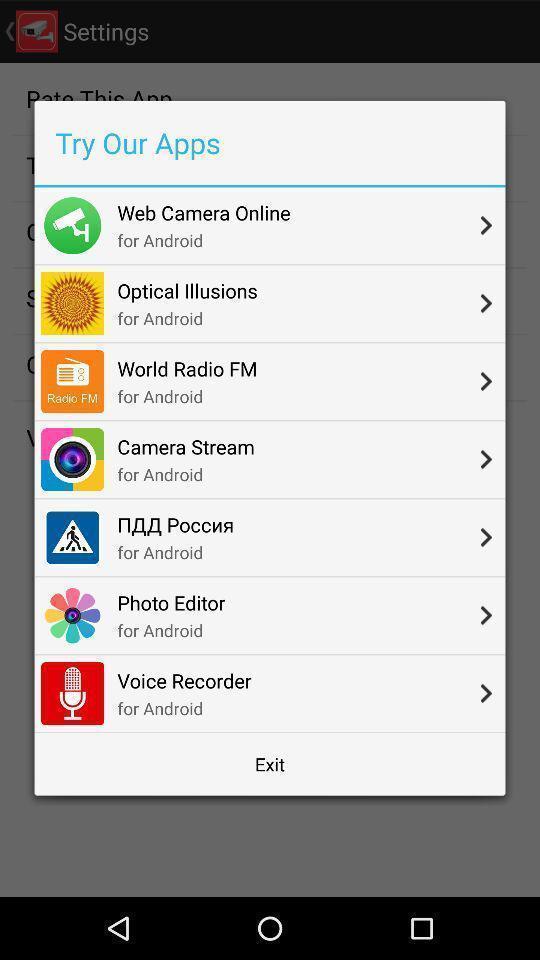Describe the content in this image. Pop-up suggested multiple apps. 